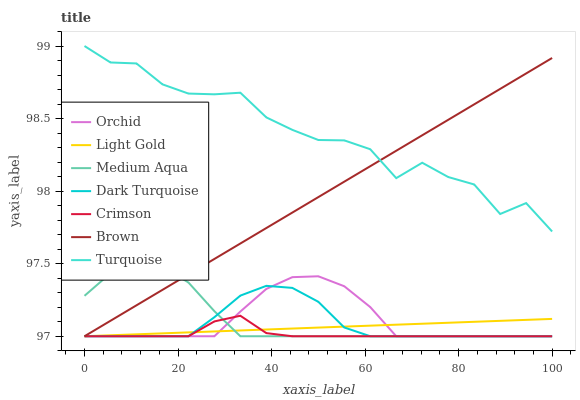Does Dark Turquoise have the minimum area under the curve?
Answer yes or no. No. Does Dark Turquoise have the maximum area under the curve?
Answer yes or no. No. Is Dark Turquoise the smoothest?
Answer yes or no. No. Is Dark Turquoise the roughest?
Answer yes or no. No. Does Turquoise have the lowest value?
Answer yes or no. No. Does Dark Turquoise have the highest value?
Answer yes or no. No. Is Crimson less than Turquoise?
Answer yes or no. Yes. Is Turquoise greater than Dark Turquoise?
Answer yes or no. Yes. Does Crimson intersect Turquoise?
Answer yes or no. No. 